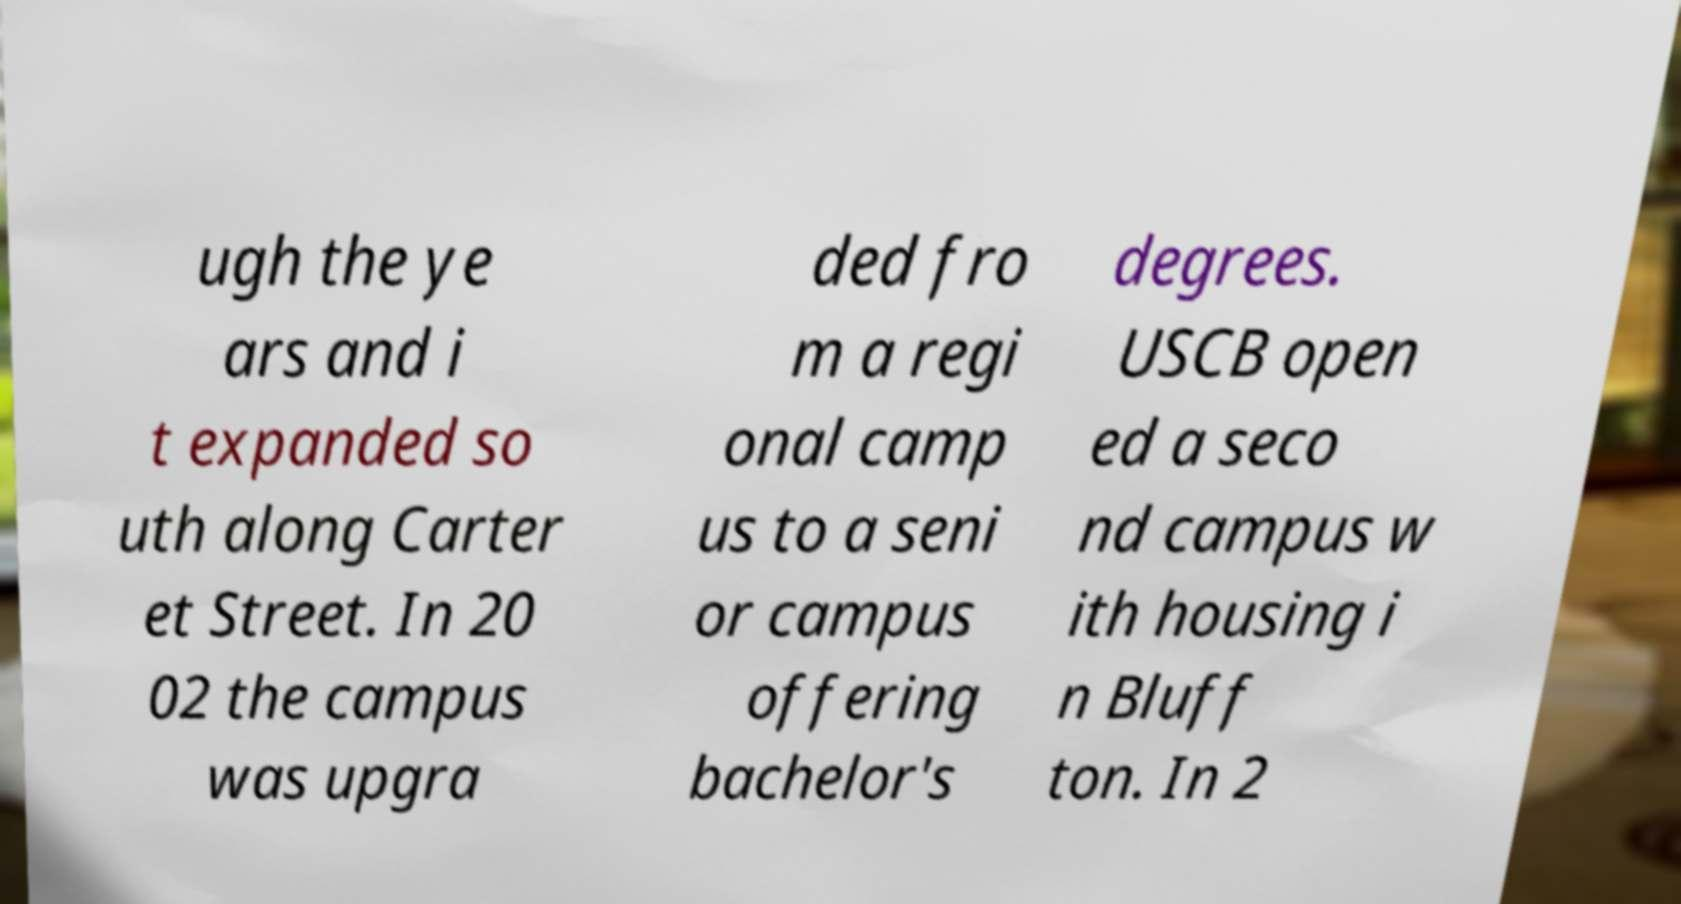What messages or text are displayed in this image? I need them in a readable, typed format. ugh the ye ars and i t expanded so uth along Carter et Street. In 20 02 the campus was upgra ded fro m a regi onal camp us to a seni or campus offering bachelor's degrees. USCB open ed a seco nd campus w ith housing i n Bluff ton. In 2 